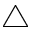Convert formula to latex. <formula><loc_0><loc_0><loc_500><loc_500>\bigtriangleup</formula> 